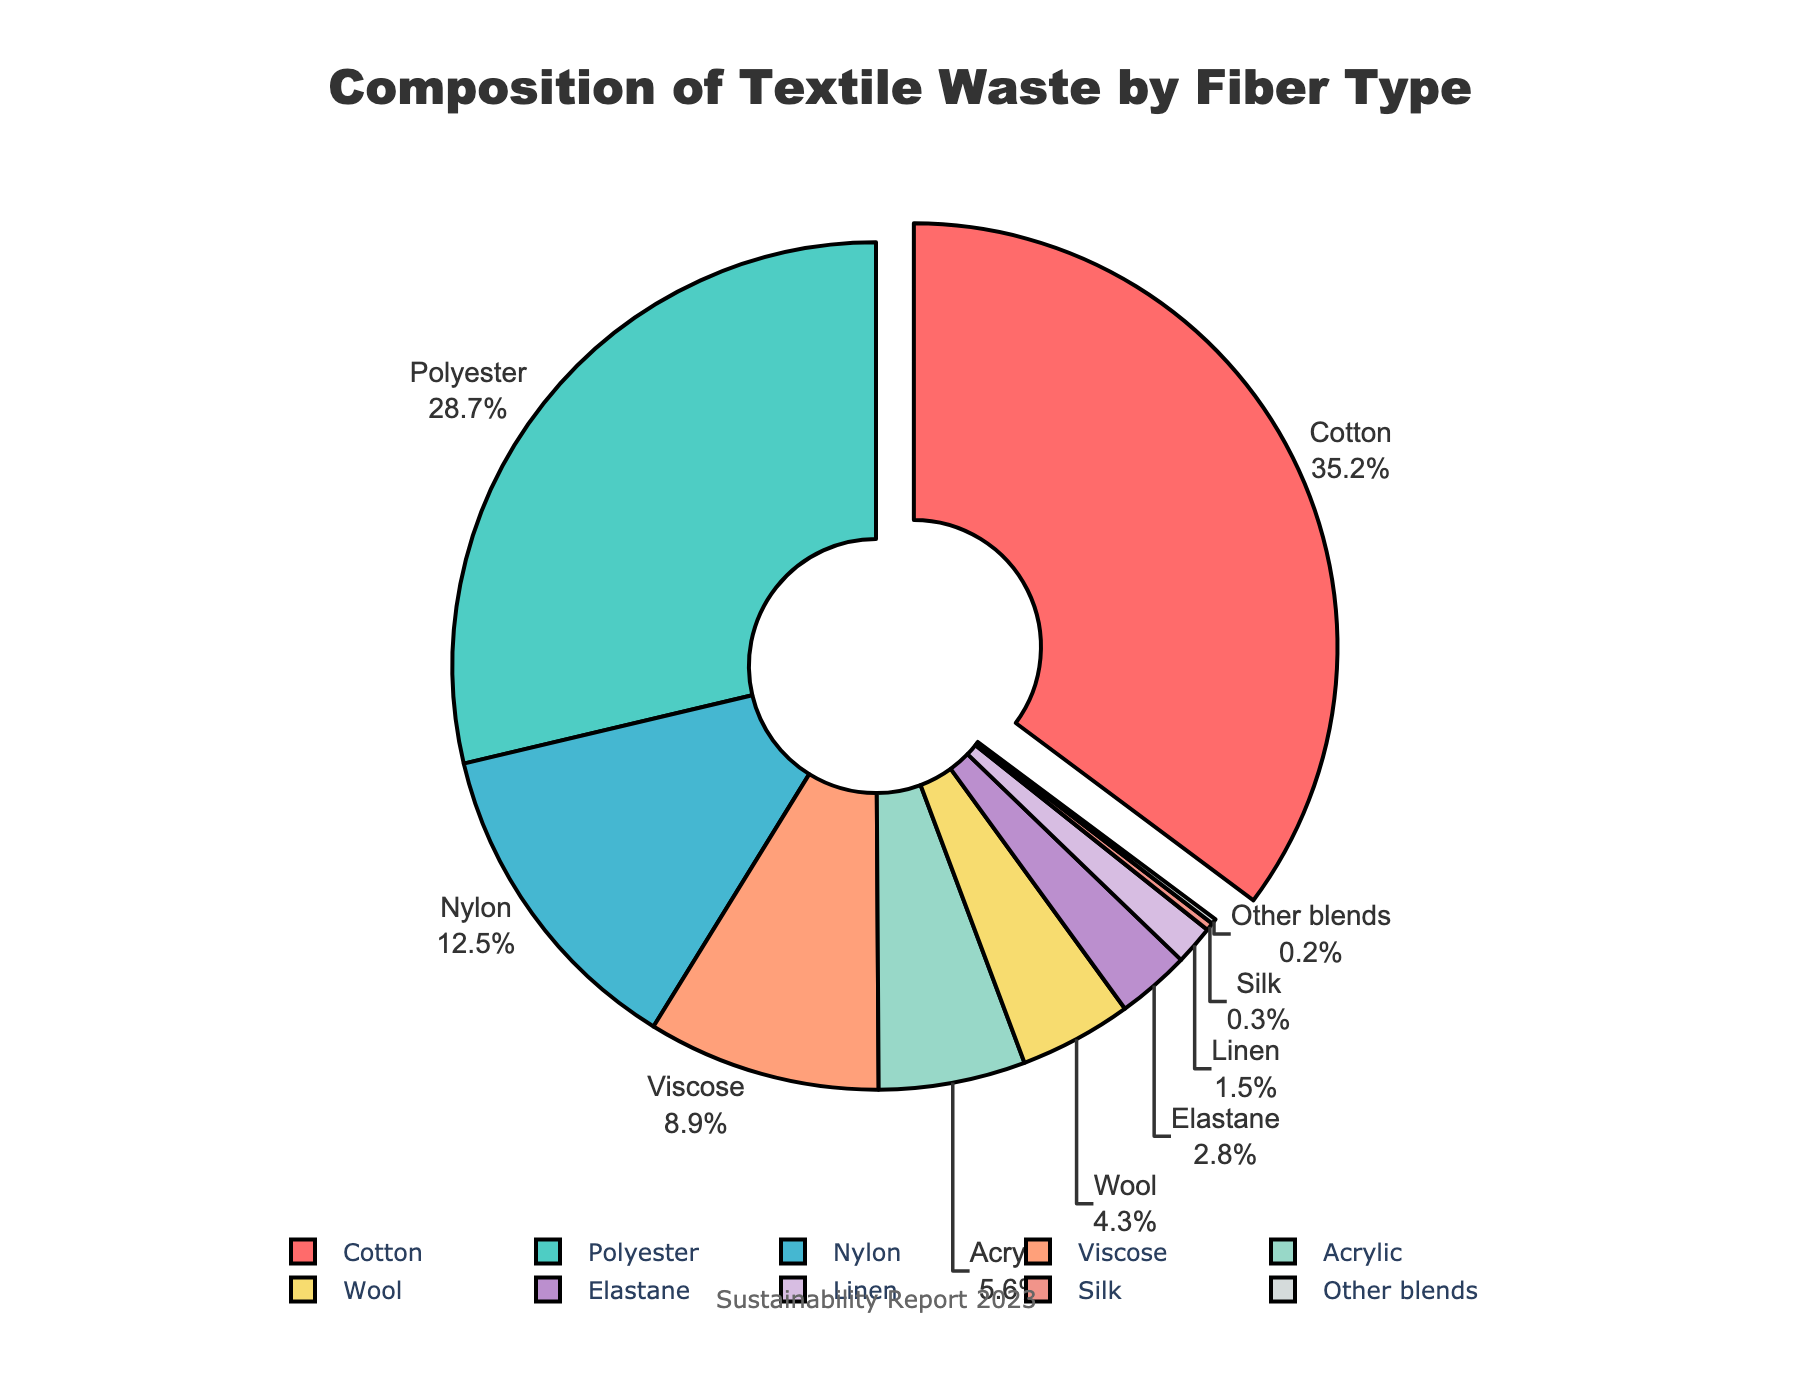what is the combined percentage of cotton, polyester, and nylon? Add the percentages for cotton (35.2%), polyester (28.7%), and nylon (12.5%). The combined percentage is 35.2 + 28.7 + 12.5 = 76.4%.
Answer: 76.4% which fiber type has the smallest percentage in the textile waste? Look at the segment with the smallest label percentage on the pie chart. "Other blends" have the smallest percentage at 0.2%.
Answer: Other blends how much larger is the percentage of cotton waste compared to viscose waste? Subtract the percentage of viscose (8.9%) from the cotton percentage (35.2%). The difference is 35.2 - 8.9 = 26.3%.
Answer: 26.3% which two fiber types are closest in waste percentage, and what are their percentages? Find the two segments with the closest percentage values. Acrylic (5.6%) and wool (4.3%) have the closest percentages, with a difference of 1.3%.
Answer: Acrylic (5.6%) and wool (4.3%) what is the total percentage of textile waste represented by fibers other than cotton and polyester? Subtract the combined percentage of cotton (35.2%) and polyester (28.7%) from 100%. The remaining percentage is 100 - 35.2 - 28.7 = 36.1%.
Answer: 36.1% which fiber type is the second most prevalent in the textile waste composition? Identify the second-largest segment in the pie chart. Polyester is the second most prevalent at 28.7%.
Answer: Polyester is silk or elastane contributing more to the textile waste? Compare the segments for silk (0.3%) and elastane (2.8%). Elastane contributes more to the waste.
Answer: Elastane what is the percentage contribution of the smallest three fiber types combined? Add the percentages for the smallest three fiber types: other blends (0.2%), silk (0.3%), and linen (1.5%). The combined percentage is 0.2 + 0.3 + 1.5 = 2.0%.
Answer: 2.0% which fiber type is represented by the largest segment pulled away from the pie chart, and what is its percentage? The segment that is pulled away from the rest indicates the maximum percentage. Cotton is the largest segment at 35.2%.
Answer: Cotton, 35.2% 